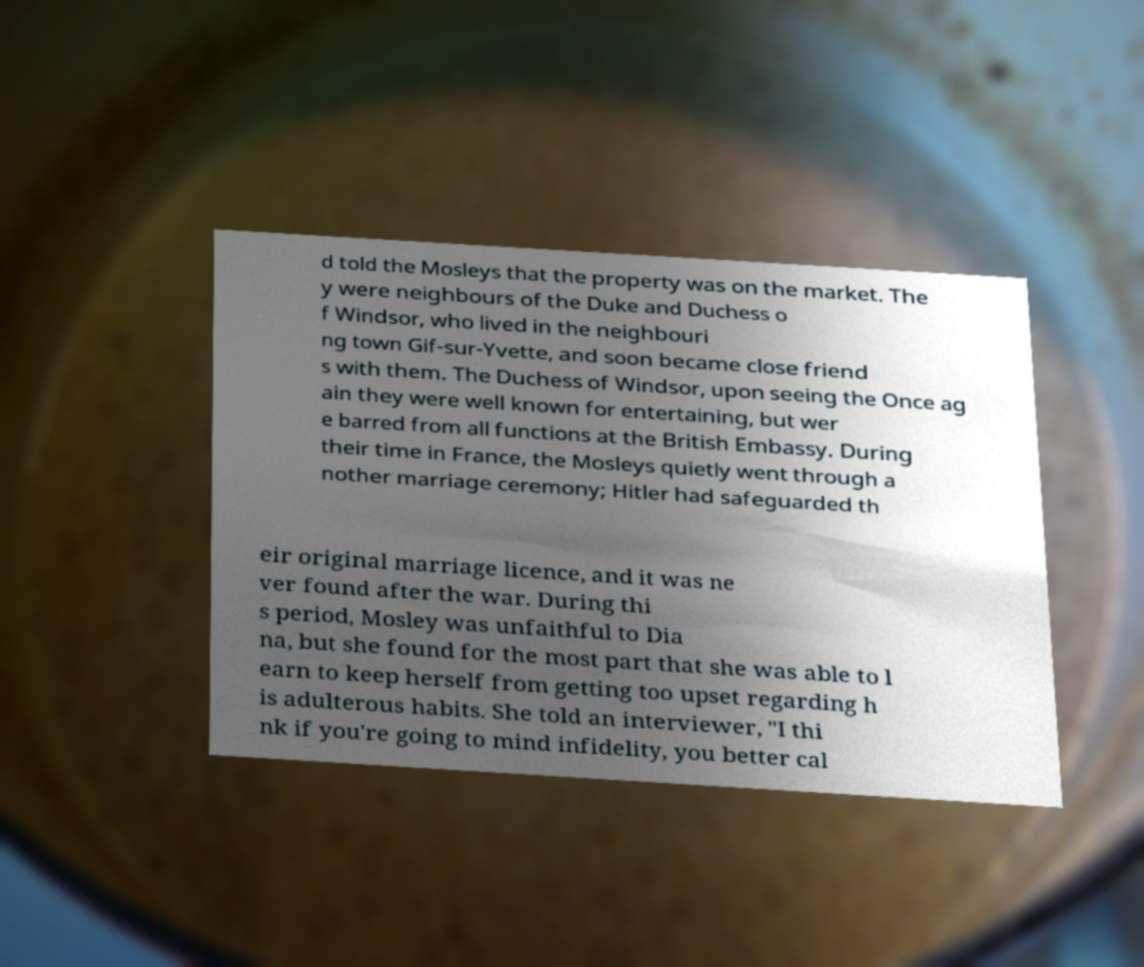Can you accurately transcribe the text from the provided image for me? d told the Mosleys that the property was on the market. The y were neighbours of the Duke and Duchess o f Windsor, who lived in the neighbouri ng town Gif-sur-Yvette, and soon became close friend s with them. The Duchess of Windsor, upon seeing the Once ag ain they were well known for entertaining, but wer e barred from all functions at the British Embassy. During their time in France, the Mosleys quietly went through a nother marriage ceremony; Hitler had safeguarded th eir original marriage licence, and it was ne ver found after the war. During thi s period, Mosley was unfaithful to Dia na, but she found for the most part that she was able to l earn to keep herself from getting too upset regarding h is adulterous habits. She told an interviewer, "I thi nk if you're going to mind infidelity, you better cal 